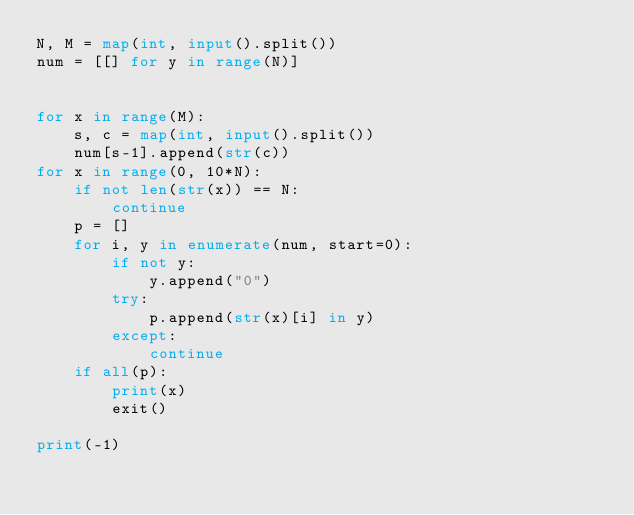Convert code to text. <code><loc_0><loc_0><loc_500><loc_500><_Python_>N, M = map(int, input().split())
num = [[] for y in range(N)]


for x in range(M):
    s, c = map(int, input().split())
    num[s-1].append(str(c))
for x in range(0, 10*N):
    if not len(str(x)) == N:
        continue
    p = []
    for i, y in enumerate(num, start=0):
        if not y:
            y.append("0")
        try:
            p.append(str(x)[i] in y)
        except:
            continue
    if all(p):
        print(x)
        exit()

print(-1)</code> 